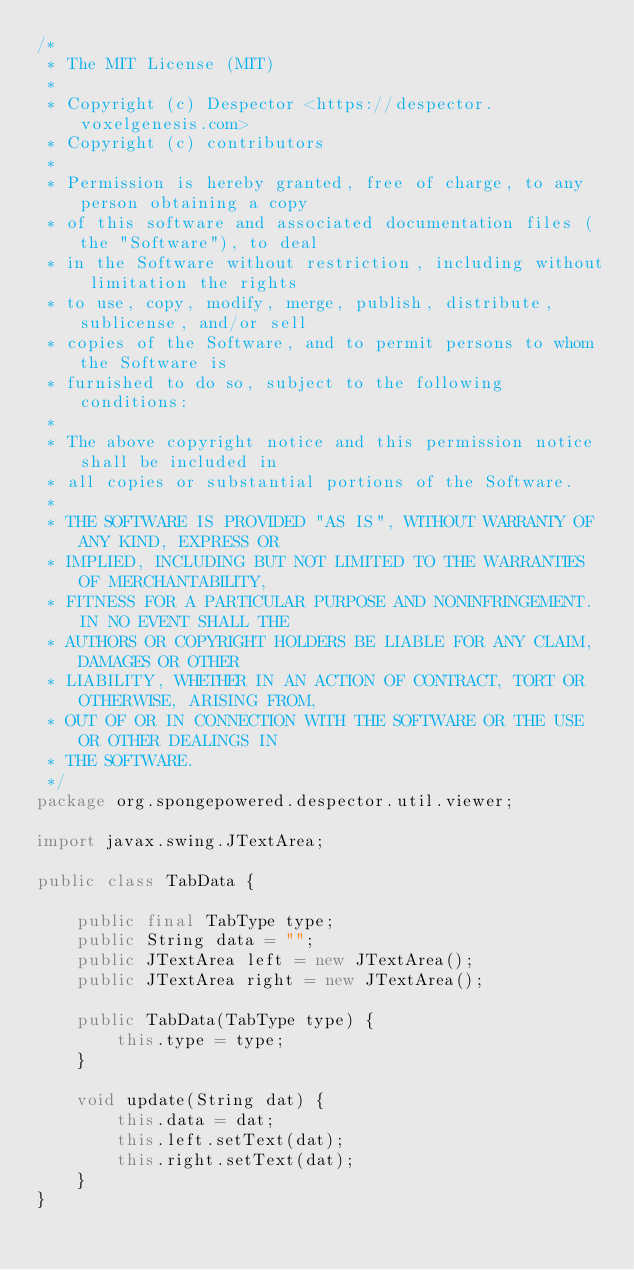<code> <loc_0><loc_0><loc_500><loc_500><_Java_>/*
 * The MIT License (MIT)
 *
 * Copyright (c) Despector <https://despector.voxelgenesis.com>
 * Copyright (c) contributors
 *
 * Permission is hereby granted, free of charge, to any person obtaining a copy
 * of this software and associated documentation files (the "Software"), to deal
 * in the Software without restriction, including without limitation the rights
 * to use, copy, modify, merge, publish, distribute, sublicense, and/or sell
 * copies of the Software, and to permit persons to whom the Software is
 * furnished to do so, subject to the following conditions:
 *
 * The above copyright notice and this permission notice shall be included in
 * all copies or substantial portions of the Software.
 *
 * THE SOFTWARE IS PROVIDED "AS IS", WITHOUT WARRANTY OF ANY KIND, EXPRESS OR
 * IMPLIED, INCLUDING BUT NOT LIMITED TO THE WARRANTIES OF MERCHANTABILITY,
 * FITNESS FOR A PARTICULAR PURPOSE AND NONINFRINGEMENT. IN NO EVENT SHALL THE
 * AUTHORS OR COPYRIGHT HOLDERS BE LIABLE FOR ANY CLAIM, DAMAGES OR OTHER
 * LIABILITY, WHETHER IN AN ACTION OF CONTRACT, TORT OR OTHERWISE, ARISING FROM,
 * OUT OF OR IN CONNECTION WITH THE SOFTWARE OR THE USE OR OTHER DEALINGS IN
 * THE SOFTWARE.
 */
package org.spongepowered.despector.util.viewer;

import javax.swing.JTextArea;

public class TabData {

    public final TabType type;
    public String data = "";
    public JTextArea left = new JTextArea();
    public JTextArea right = new JTextArea();

    public TabData(TabType type) {
        this.type = type;
    }

    void update(String dat) {
        this.data = dat;
        this.left.setText(dat);
        this.right.setText(dat);
    }
}
</code> 